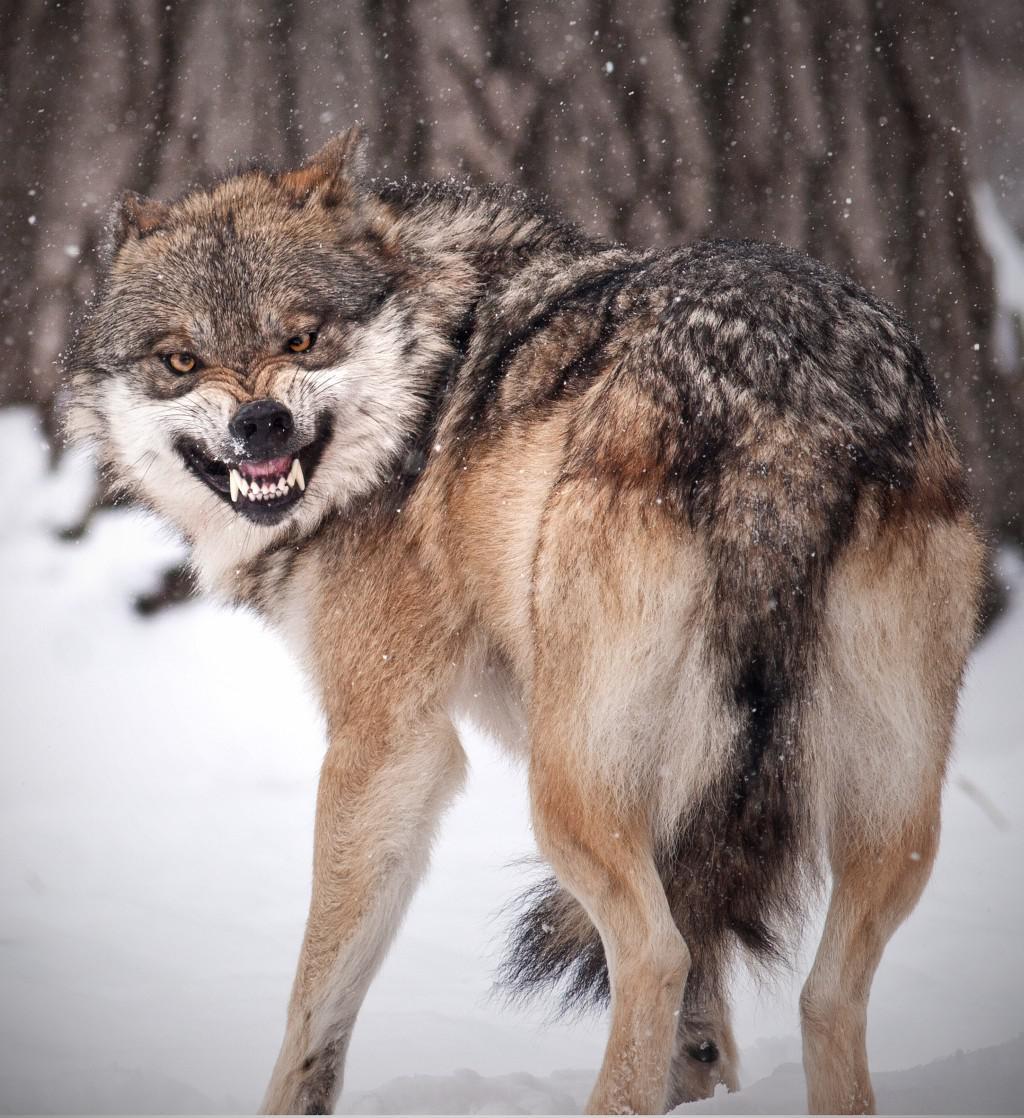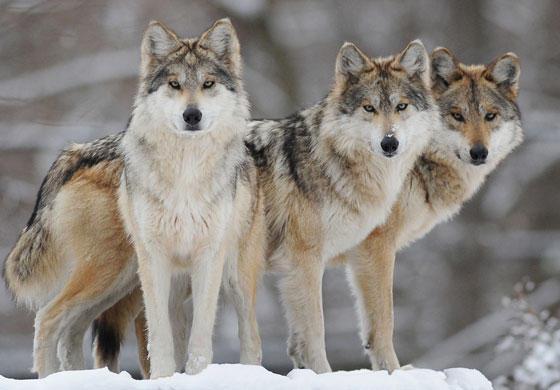The first image is the image on the left, the second image is the image on the right. Examine the images to the left and right. Is the description "The right image contains at least two wolves." accurate? Answer yes or no. Yes. 